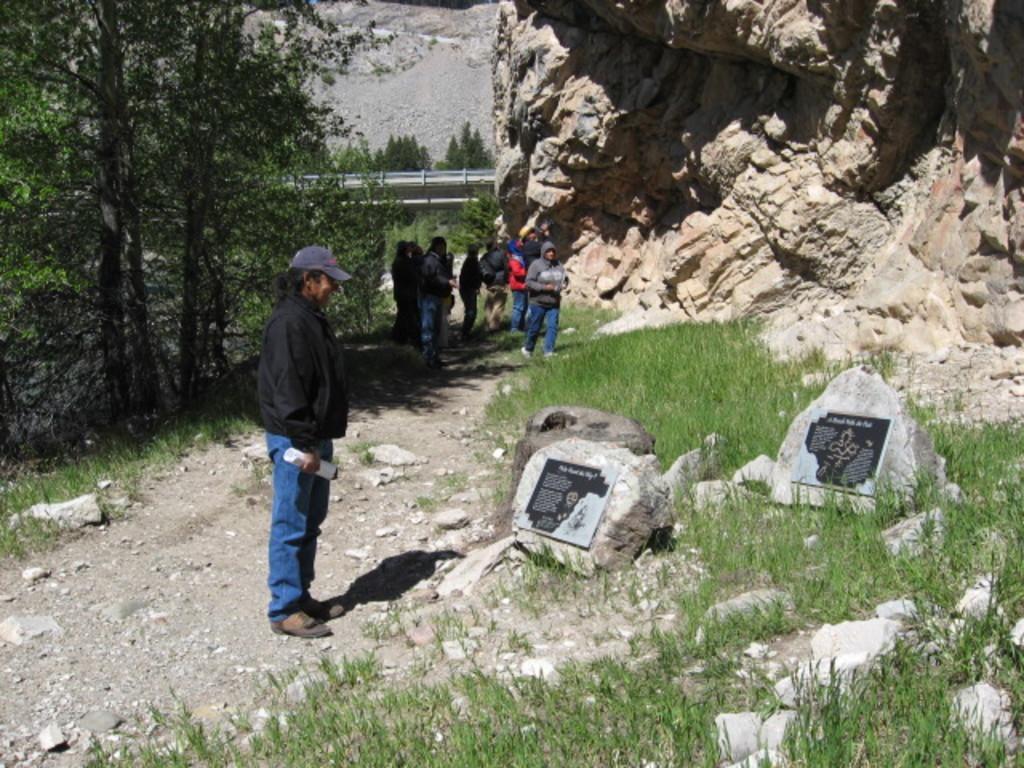How would you summarize this image in a sentence or two? In this picture we can see the hills, people. In the background it seems like the railing. In this picture we can see the trees. We can see a person wearing a cap and holding some white object, standing. On the right side of the picture we can see the green grass, on the rocks we can see the boards with some information. 